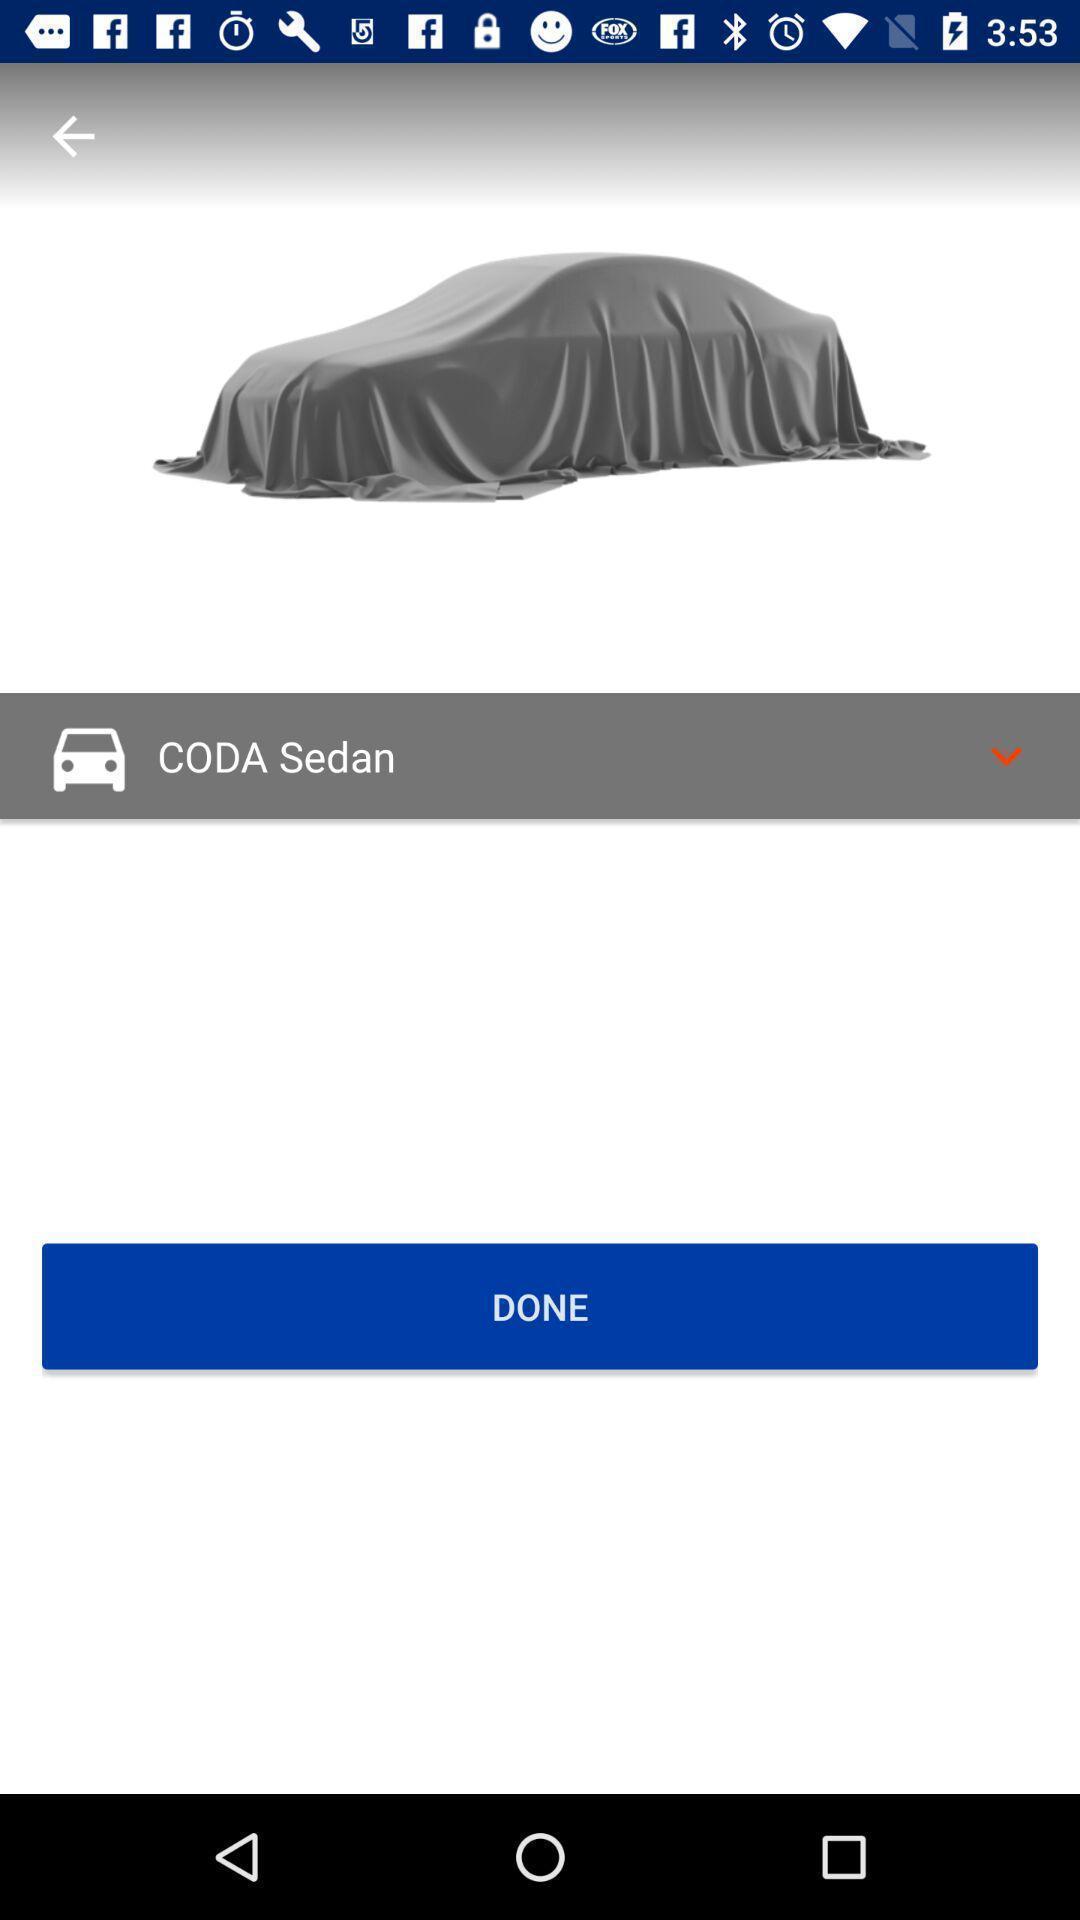Describe the key features of this screenshot. Screen displaying product and product name. 